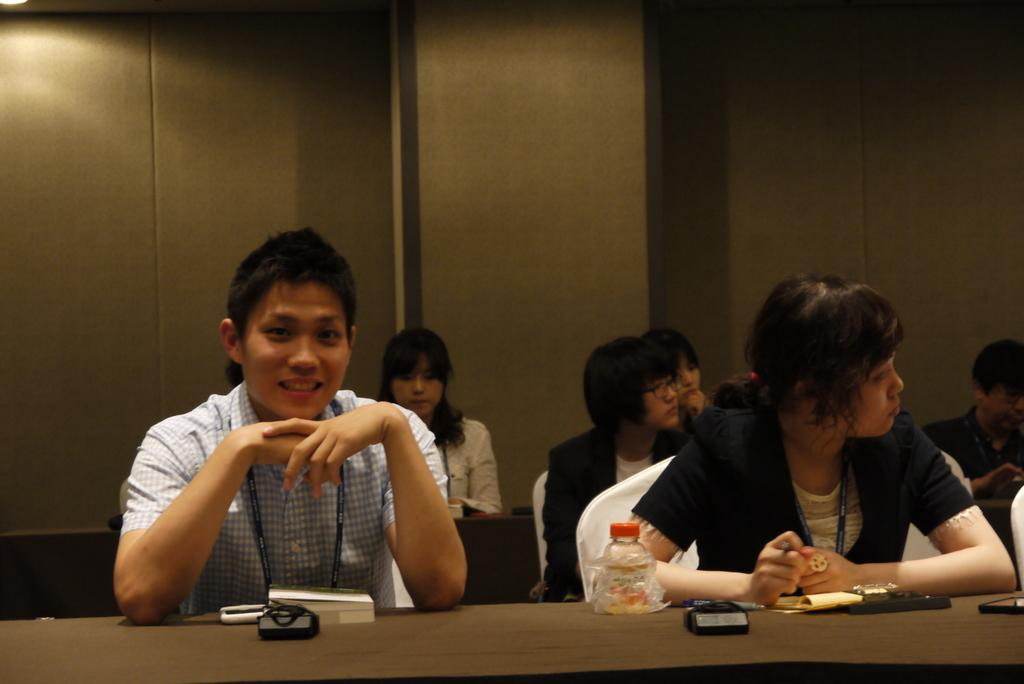What is the man on the left side of the image doing? The man is sitting on a chair on the left side of the image. What is the man's facial expression? The man is smiling. Are there any other people in the image? Yes, there are other people sitting on chairs in the image. Reasoning: Let' Let's think step by step in order to produce the conversation. We start by identifying the main subject in the image, which is the man sitting on a chair. Then, we describe his facial expression, which is smiling. Finally, we acknowledge the presence of other people in the image, who are also sitting on chairs. Each question is designed to elicit a specific detail about the image that is known from the provided facts. Absurd Question/Answer: What type of flesh can be seen on the playground in the image? There is no playground or flesh present in the image. How many oranges are visible on the man's chair in the image? There are no oranges visible on the man's chair or anywhere else in the image. 